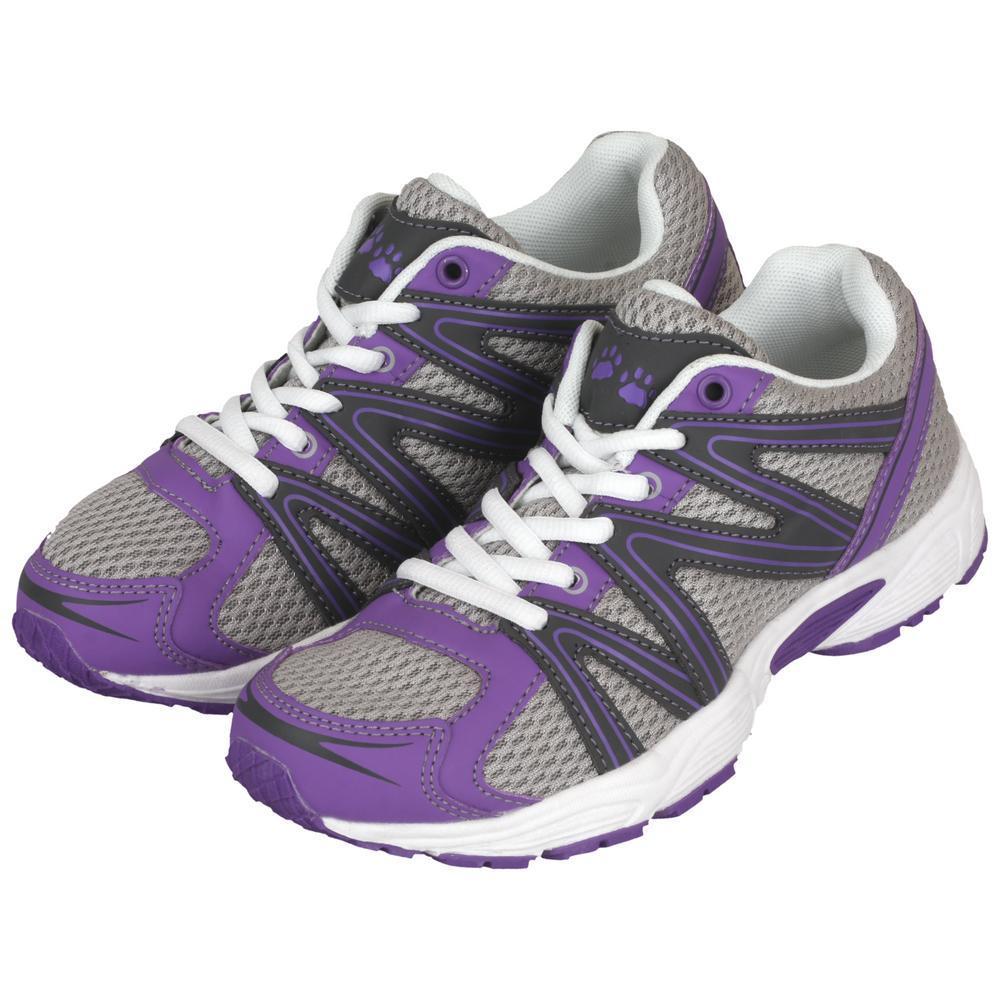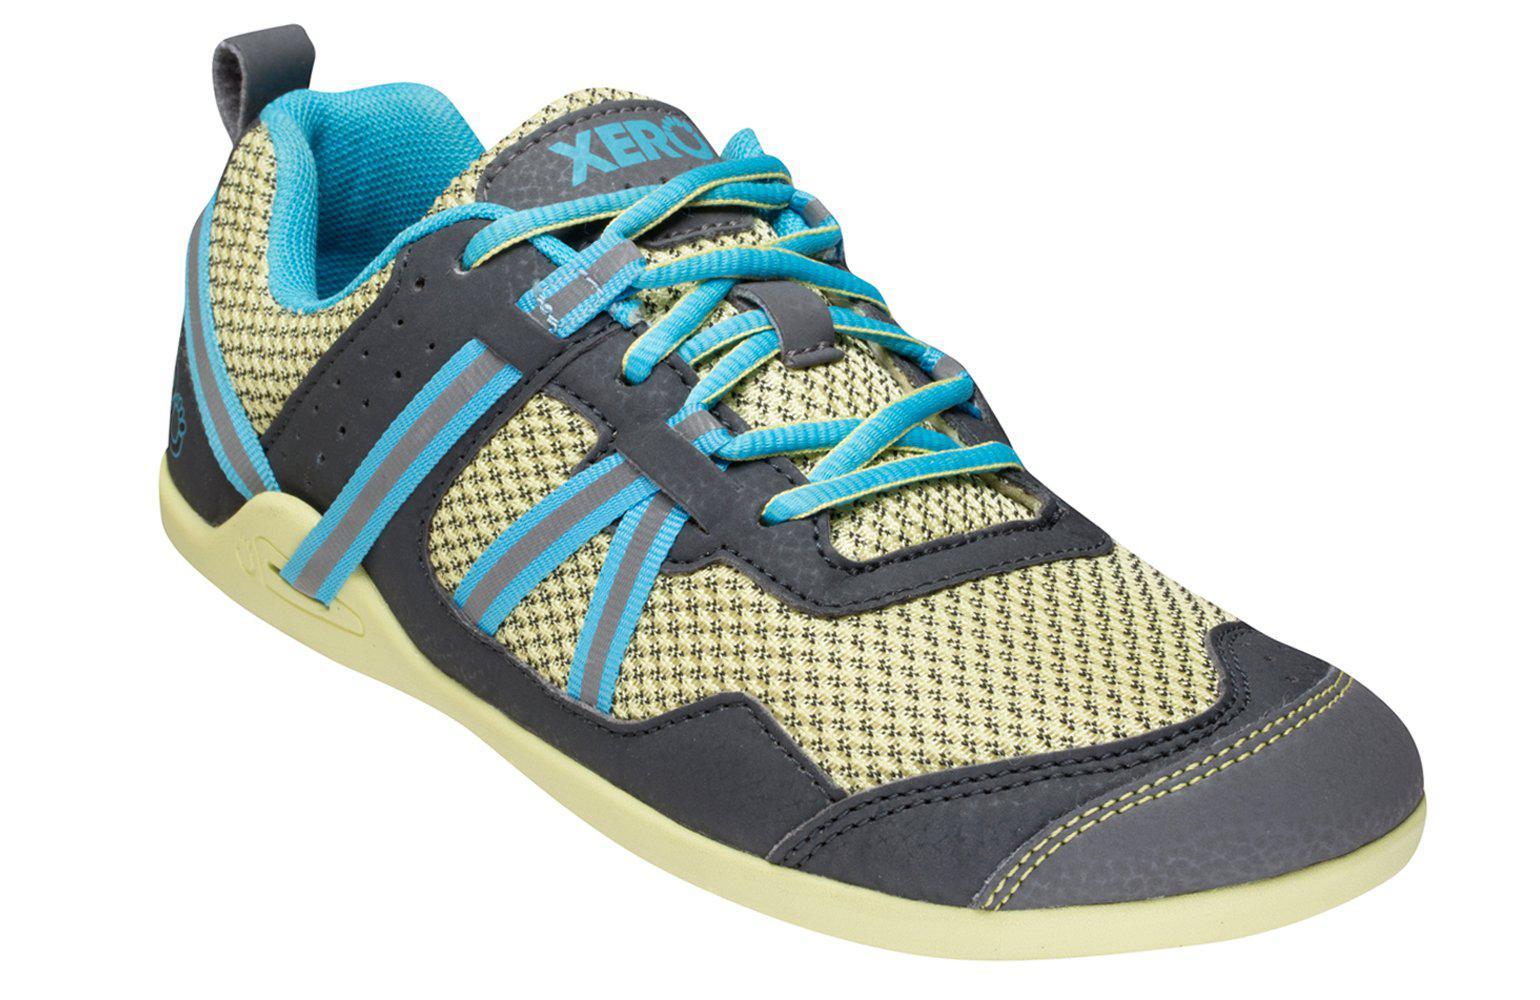The first image is the image on the left, the second image is the image on the right. Assess this claim about the two images: "Exactly three shoes are shown, a pair in one image with one turned over with visible sole treads, while a single shoe in the other image is a different color scheme and design.". Correct or not? Answer yes or no. No. The first image is the image on the left, the second image is the image on the right. Considering the images on both sides, is "At least one sneaker incorporates purple in its design." valid? Answer yes or no. Yes. 